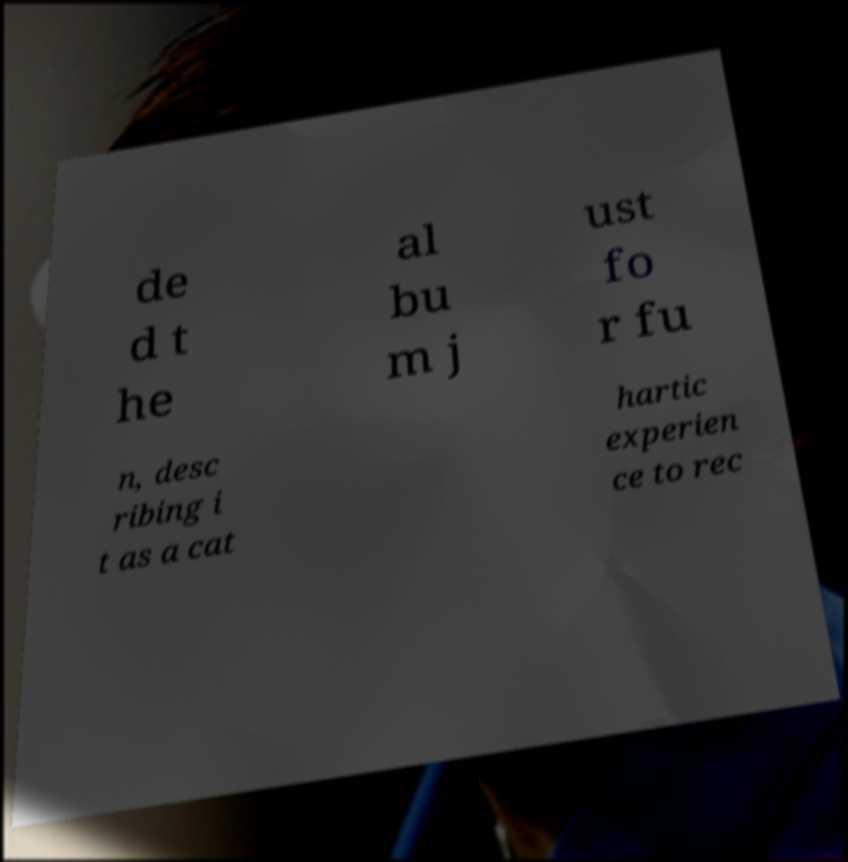Could you extract and type out the text from this image? de d t he al bu m j ust fo r fu n, desc ribing i t as a cat hartic experien ce to rec 